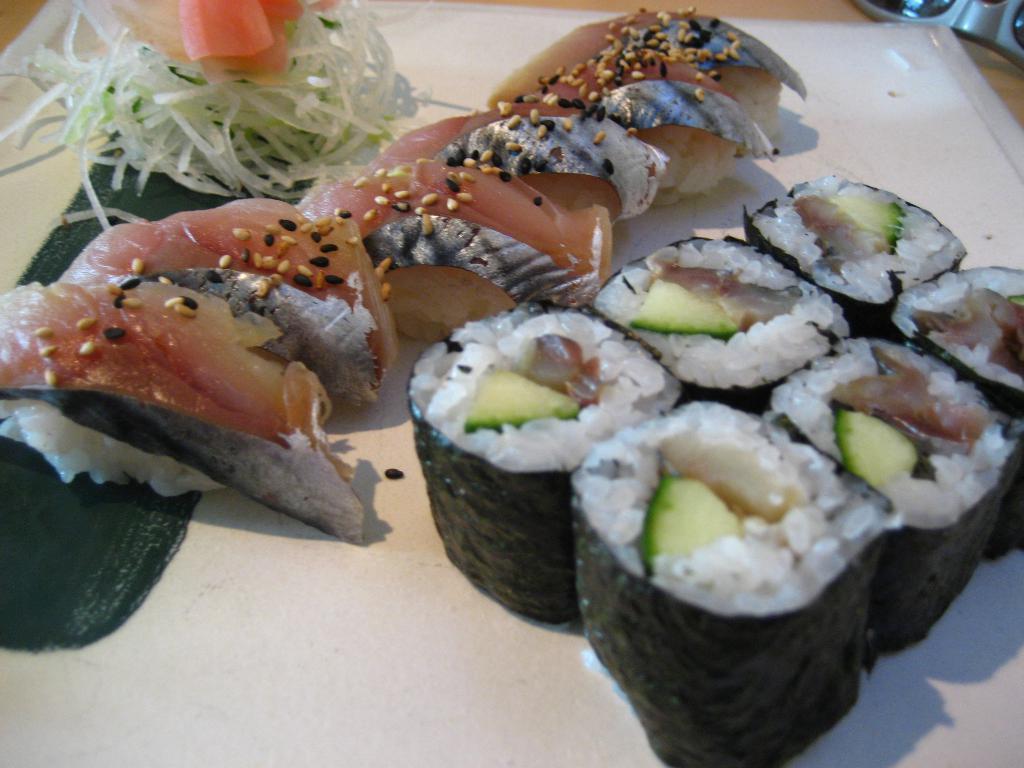How would you summarize this image in a sentence or two? In the image there is a sushi and some other Thai food placed on a plate. 